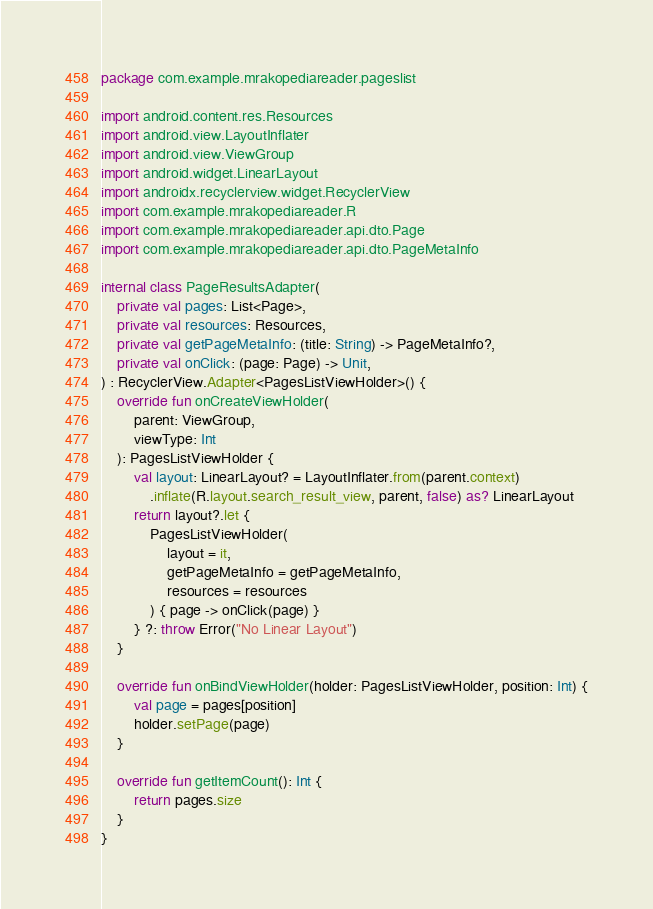Convert code to text. <code><loc_0><loc_0><loc_500><loc_500><_Kotlin_>package com.example.mrakopediareader.pageslist

import android.content.res.Resources
import android.view.LayoutInflater
import android.view.ViewGroup
import android.widget.LinearLayout
import androidx.recyclerview.widget.RecyclerView
import com.example.mrakopediareader.R
import com.example.mrakopediareader.api.dto.Page
import com.example.mrakopediareader.api.dto.PageMetaInfo

internal class PageResultsAdapter(
    private val pages: List<Page>,
    private val resources: Resources,
    private val getPageMetaInfo: (title: String) -> PageMetaInfo?,
    private val onClick: (page: Page) -> Unit,
) : RecyclerView.Adapter<PagesListViewHolder>() {
    override fun onCreateViewHolder(
        parent: ViewGroup,
        viewType: Int
    ): PagesListViewHolder {
        val layout: LinearLayout? = LayoutInflater.from(parent.context)
            .inflate(R.layout.search_result_view, parent, false) as? LinearLayout
        return layout?.let {
            PagesListViewHolder(
                layout = it,
                getPageMetaInfo = getPageMetaInfo,
                resources = resources
            ) { page -> onClick(page) }
        } ?: throw Error("No Linear Layout")
    }

    override fun onBindViewHolder(holder: PagesListViewHolder, position: Int) {
        val page = pages[position]
        holder.setPage(page)
    }

    override fun getItemCount(): Int {
        return pages.size
    }
}</code> 